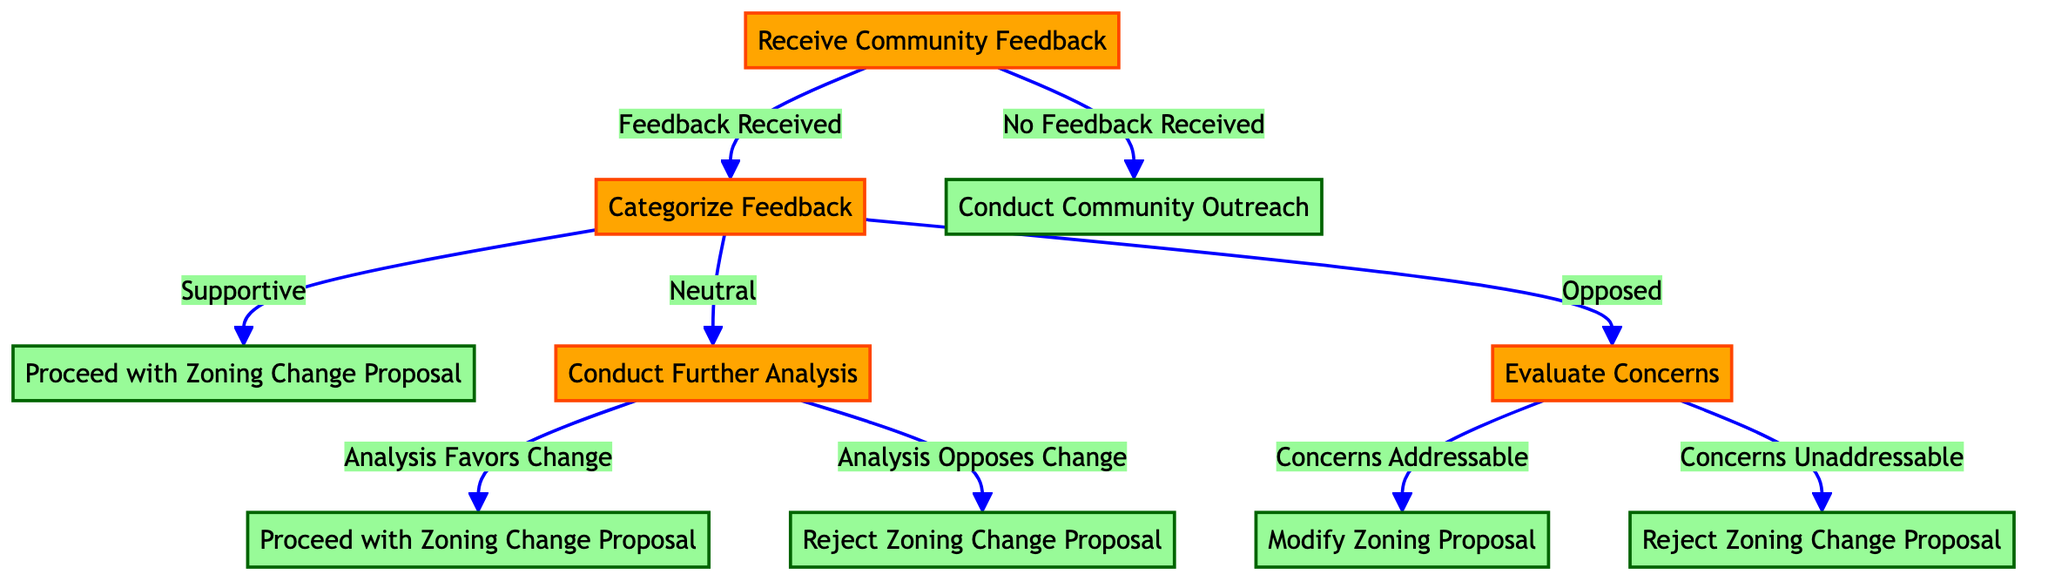What's the first action in the decision tree? The first action after receiving community feedback is "Categorize Feedback". This is identified as the first branch leading from the initial node "Receive Community Feedback".
Answer: Categorize Feedback How many main outcomes are there after receiving community feedback? After categorizing feedback into supportive, neutral, and opposed, there are two main outcomes for supportive (proceed with zoning change) and neutral (further analysis), while opposed leads to evaluating concerns. Counting these options gives three main outcomes.
Answer: Three If the feedback is opposed, what is the first decision step? The first decision step after identifying the feedback as opposed is "Evaluate Concerns". This is the next branch following the opposed option.
Answer: Evaluate Concerns What decision follows if the analysis favors change? If the analysis conducted after receiving neutral feedback favors change, the next step is to "Proceed with Zoning Change Proposal". This follows directly from the decision node where the analysis outcome is favorable.
Answer: Proceed with Zoning Change Proposal What happens if no feedback is received? If no feedback is received, the action taken is to "Conduct Community Outreach". This is the direct action branch leading from the "No Feedback Received" option.
Answer: Conduct Community Outreach How many branches lead from categorizing feedback? There are three branches leading from categorizing feedback, which include supportive, neutral, and opposed. Each category dictates a different subsequent action or decision node.
Answer: Three What action is taken if concerns are addressable? If the concerns raised by opposed feedback are found to be addressable, the action taken is to "Modify Zoning Proposal". This follows the decision path pertaining to addressable concerns.
Answer: Modify Zoning Proposal What is the action taken if feedback is neutral and analysis opposes change? If the feedback is neutral and the subsequent analysis opposes change, the action will be to "Reject Zoning Change Proposal". This follows the sequence from neutral feedback to analysis and then leads to action.
Answer: Reject Zoning Change Proposal 